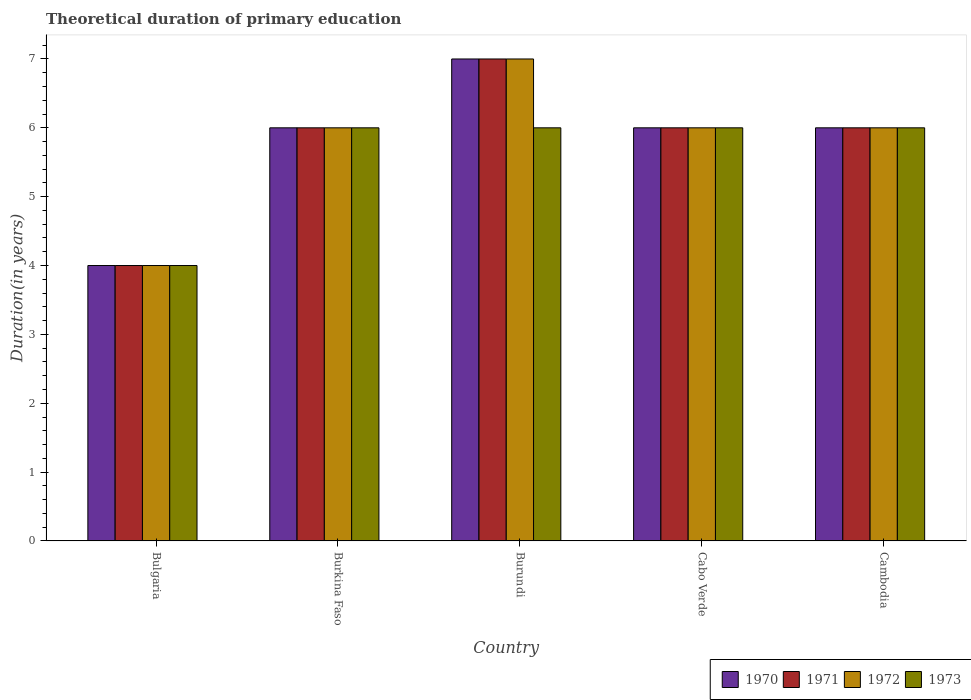Are the number of bars per tick equal to the number of legend labels?
Your answer should be compact. Yes. Are the number of bars on each tick of the X-axis equal?
Offer a terse response. Yes. How many bars are there on the 3rd tick from the right?
Your answer should be compact. 4. What is the label of the 2nd group of bars from the left?
Offer a very short reply. Burkina Faso. In which country was the total theoretical duration of primary education in 1973 maximum?
Your answer should be compact. Burkina Faso. In which country was the total theoretical duration of primary education in 1970 minimum?
Offer a terse response. Bulgaria. What is the total total theoretical duration of primary education in 1971 in the graph?
Your response must be concise. 29. What is the ratio of the total theoretical duration of primary education in 1972 in Bulgaria to that in Cabo Verde?
Provide a succinct answer. 0.67. Is the difference between the total theoretical duration of primary education in 1971 in Bulgaria and Cambodia greater than the difference between the total theoretical duration of primary education in 1972 in Bulgaria and Cambodia?
Make the answer very short. No. What is the difference between the highest and the lowest total theoretical duration of primary education in 1971?
Your response must be concise. 3. Is it the case that in every country, the sum of the total theoretical duration of primary education in 1972 and total theoretical duration of primary education in 1971 is greater than the sum of total theoretical duration of primary education in 1970 and total theoretical duration of primary education in 1973?
Make the answer very short. No. What does the 2nd bar from the left in Cambodia represents?
Provide a short and direct response. 1971. Is it the case that in every country, the sum of the total theoretical duration of primary education in 1970 and total theoretical duration of primary education in 1971 is greater than the total theoretical duration of primary education in 1973?
Your answer should be compact. Yes. How many countries are there in the graph?
Provide a succinct answer. 5. What is the difference between two consecutive major ticks on the Y-axis?
Offer a terse response. 1. Are the values on the major ticks of Y-axis written in scientific E-notation?
Offer a very short reply. No. How many legend labels are there?
Keep it short and to the point. 4. What is the title of the graph?
Offer a terse response. Theoretical duration of primary education. Does "2013" appear as one of the legend labels in the graph?
Your response must be concise. No. What is the label or title of the Y-axis?
Give a very brief answer. Duration(in years). What is the Duration(in years) in 1970 in Bulgaria?
Ensure brevity in your answer.  4. What is the Duration(in years) in 1971 in Bulgaria?
Keep it short and to the point. 4. What is the Duration(in years) of 1972 in Bulgaria?
Ensure brevity in your answer.  4. What is the Duration(in years) of 1973 in Bulgaria?
Your response must be concise. 4. What is the Duration(in years) of 1970 in Burkina Faso?
Provide a succinct answer. 6. What is the Duration(in years) in 1973 in Burkina Faso?
Provide a succinct answer. 6. What is the Duration(in years) in 1970 in Cabo Verde?
Your answer should be compact. 6. What is the Duration(in years) of 1973 in Cabo Verde?
Keep it short and to the point. 6. What is the Duration(in years) in 1971 in Cambodia?
Provide a succinct answer. 6. What is the Duration(in years) of 1972 in Cambodia?
Offer a very short reply. 6. Across all countries, what is the maximum Duration(in years) in 1970?
Provide a short and direct response. 7. Across all countries, what is the maximum Duration(in years) in 1971?
Keep it short and to the point. 7. Across all countries, what is the minimum Duration(in years) of 1970?
Offer a terse response. 4. Across all countries, what is the minimum Duration(in years) of 1971?
Make the answer very short. 4. Across all countries, what is the minimum Duration(in years) in 1972?
Your answer should be compact. 4. What is the total Duration(in years) in 1970 in the graph?
Your answer should be compact. 29. What is the total Duration(in years) of 1971 in the graph?
Provide a succinct answer. 29. What is the total Duration(in years) in 1973 in the graph?
Your answer should be very brief. 28. What is the difference between the Duration(in years) in 1971 in Bulgaria and that in Burkina Faso?
Your response must be concise. -2. What is the difference between the Duration(in years) of 1972 in Bulgaria and that in Burkina Faso?
Provide a succinct answer. -2. What is the difference between the Duration(in years) of 1972 in Bulgaria and that in Burundi?
Give a very brief answer. -3. What is the difference between the Duration(in years) of 1973 in Bulgaria and that in Cabo Verde?
Your answer should be compact. -2. What is the difference between the Duration(in years) of 1970 in Bulgaria and that in Cambodia?
Offer a very short reply. -2. What is the difference between the Duration(in years) of 1972 in Bulgaria and that in Cambodia?
Offer a very short reply. -2. What is the difference between the Duration(in years) of 1970 in Burkina Faso and that in Burundi?
Your answer should be very brief. -1. What is the difference between the Duration(in years) in 1971 in Burkina Faso and that in Burundi?
Your response must be concise. -1. What is the difference between the Duration(in years) of 1972 in Burkina Faso and that in Burundi?
Your response must be concise. -1. What is the difference between the Duration(in years) of 1970 in Burkina Faso and that in Cabo Verde?
Keep it short and to the point. 0. What is the difference between the Duration(in years) in 1971 in Burkina Faso and that in Cabo Verde?
Your response must be concise. 0. What is the difference between the Duration(in years) in 1972 in Burkina Faso and that in Cabo Verde?
Provide a succinct answer. 0. What is the difference between the Duration(in years) in 1973 in Burkina Faso and that in Cabo Verde?
Offer a terse response. 0. What is the difference between the Duration(in years) of 1970 in Burundi and that in Cabo Verde?
Give a very brief answer. 1. What is the difference between the Duration(in years) of 1971 in Burundi and that in Cambodia?
Keep it short and to the point. 1. What is the difference between the Duration(in years) of 1972 in Burundi and that in Cambodia?
Your response must be concise. 1. What is the difference between the Duration(in years) of 1973 in Burundi and that in Cambodia?
Provide a succinct answer. 0. What is the difference between the Duration(in years) in 1970 in Cabo Verde and that in Cambodia?
Provide a succinct answer. 0. What is the difference between the Duration(in years) of 1971 in Cabo Verde and that in Cambodia?
Offer a very short reply. 0. What is the difference between the Duration(in years) of 1972 in Cabo Verde and that in Cambodia?
Provide a succinct answer. 0. What is the difference between the Duration(in years) of 1970 in Bulgaria and the Duration(in years) of 1971 in Burkina Faso?
Make the answer very short. -2. What is the difference between the Duration(in years) in 1970 in Bulgaria and the Duration(in years) in 1973 in Burkina Faso?
Your answer should be compact. -2. What is the difference between the Duration(in years) in 1971 in Bulgaria and the Duration(in years) in 1972 in Burkina Faso?
Your response must be concise. -2. What is the difference between the Duration(in years) of 1971 in Bulgaria and the Duration(in years) of 1973 in Burkina Faso?
Make the answer very short. -2. What is the difference between the Duration(in years) of 1970 in Bulgaria and the Duration(in years) of 1972 in Burundi?
Keep it short and to the point. -3. What is the difference between the Duration(in years) in 1970 in Bulgaria and the Duration(in years) in 1973 in Burundi?
Ensure brevity in your answer.  -2. What is the difference between the Duration(in years) in 1971 in Bulgaria and the Duration(in years) in 1973 in Burundi?
Keep it short and to the point. -2. What is the difference between the Duration(in years) of 1972 in Bulgaria and the Duration(in years) of 1973 in Burundi?
Your answer should be very brief. -2. What is the difference between the Duration(in years) in 1970 in Bulgaria and the Duration(in years) in 1971 in Cabo Verde?
Provide a succinct answer. -2. What is the difference between the Duration(in years) of 1970 in Bulgaria and the Duration(in years) of 1972 in Cambodia?
Make the answer very short. -2. What is the difference between the Duration(in years) in 1970 in Bulgaria and the Duration(in years) in 1973 in Cambodia?
Provide a short and direct response. -2. What is the difference between the Duration(in years) of 1971 in Bulgaria and the Duration(in years) of 1973 in Cambodia?
Make the answer very short. -2. What is the difference between the Duration(in years) in 1970 in Burkina Faso and the Duration(in years) in 1971 in Burundi?
Provide a succinct answer. -1. What is the difference between the Duration(in years) in 1970 in Burkina Faso and the Duration(in years) in 1973 in Burundi?
Ensure brevity in your answer.  0. What is the difference between the Duration(in years) in 1971 in Burkina Faso and the Duration(in years) in 1972 in Burundi?
Ensure brevity in your answer.  -1. What is the difference between the Duration(in years) in 1970 in Burkina Faso and the Duration(in years) in 1971 in Cabo Verde?
Your answer should be compact. 0. What is the difference between the Duration(in years) of 1970 in Burkina Faso and the Duration(in years) of 1972 in Cabo Verde?
Your answer should be very brief. 0. What is the difference between the Duration(in years) of 1970 in Burkina Faso and the Duration(in years) of 1973 in Cabo Verde?
Your answer should be very brief. 0. What is the difference between the Duration(in years) of 1971 in Burkina Faso and the Duration(in years) of 1972 in Cabo Verde?
Offer a terse response. 0. What is the difference between the Duration(in years) of 1971 in Burkina Faso and the Duration(in years) of 1973 in Cabo Verde?
Your answer should be very brief. 0. What is the difference between the Duration(in years) in 1972 in Burkina Faso and the Duration(in years) in 1973 in Cabo Verde?
Keep it short and to the point. 0. What is the difference between the Duration(in years) of 1970 in Burkina Faso and the Duration(in years) of 1971 in Cambodia?
Your response must be concise. 0. What is the difference between the Duration(in years) in 1971 in Burkina Faso and the Duration(in years) in 1972 in Cambodia?
Your answer should be compact. 0. What is the difference between the Duration(in years) in 1970 in Burundi and the Duration(in years) in 1972 in Cabo Verde?
Keep it short and to the point. 1. What is the difference between the Duration(in years) of 1970 in Burundi and the Duration(in years) of 1973 in Cabo Verde?
Provide a short and direct response. 1. What is the difference between the Duration(in years) in 1971 in Burundi and the Duration(in years) in 1973 in Cabo Verde?
Make the answer very short. 1. What is the difference between the Duration(in years) of 1970 in Burundi and the Duration(in years) of 1971 in Cambodia?
Your answer should be compact. 1. What is the difference between the Duration(in years) in 1970 in Burundi and the Duration(in years) in 1973 in Cambodia?
Provide a succinct answer. 1. What is the difference between the Duration(in years) of 1971 in Burundi and the Duration(in years) of 1973 in Cambodia?
Provide a short and direct response. 1. What is the difference between the Duration(in years) of 1972 in Burundi and the Duration(in years) of 1973 in Cambodia?
Your answer should be compact. 1. What is the difference between the Duration(in years) in 1970 in Cabo Verde and the Duration(in years) in 1971 in Cambodia?
Offer a very short reply. 0. What is the difference between the Duration(in years) in 1970 in Cabo Verde and the Duration(in years) in 1972 in Cambodia?
Offer a terse response. 0. What is the difference between the Duration(in years) of 1971 in Cabo Verde and the Duration(in years) of 1972 in Cambodia?
Make the answer very short. 0. What is the average Duration(in years) in 1972 per country?
Your answer should be compact. 5.8. What is the average Duration(in years) in 1973 per country?
Provide a short and direct response. 5.6. What is the difference between the Duration(in years) of 1970 and Duration(in years) of 1971 in Bulgaria?
Provide a short and direct response. 0. What is the difference between the Duration(in years) of 1970 and Duration(in years) of 1973 in Bulgaria?
Your response must be concise. 0. What is the difference between the Duration(in years) of 1971 and Duration(in years) of 1972 in Bulgaria?
Keep it short and to the point. 0. What is the difference between the Duration(in years) in 1971 and Duration(in years) in 1973 in Bulgaria?
Offer a very short reply. 0. What is the difference between the Duration(in years) of 1970 and Duration(in years) of 1972 in Burkina Faso?
Offer a very short reply. 0. What is the difference between the Duration(in years) in 1971 and Duration(in years) in 1972 in Burkina Faso?
Provide a succinct answer. 0. What is the difference between the Duration(in years) of 1972 and Duration(in years) of 1973 in Burkina Faso?
Provide a succinct answer. 0. What is the difference between the Duration(in years) in 1971 and Duration(in years) in 1972 in Burundi?
Provide a succinct answer. 0. What is the difference between the Duration(in years) of 1972 and Duration(in years) of 1973 in Burundi?
Provide a succinct answer. 1. What is the difference between the Duration(in years) in 1970 and Duration(in years) in 1972 in Cabo Verde?
Your answer should be very brief. 0. What is the difference between the Duration(in years) in 1970 and Duration(in years) in 1971 in Cambodia?
Your response must be concise. 0. What is the difference between the Duration(in years) in 1970 and Duration(in years) in 1972 in Cambodia?
Give a very brief answer. 0. What is the difference between the Duration(in years) in 1971 and Duration(in years) in 1973 in Cambodia?
Your answer should be compact. 0. What is the ratio of the Duration(in years) of 1972 in Bulgaria to that in Burkina Faso?
Keep it short and to the point. 0.67. What is the ratio of the Duration(in years) of 1973 in Bulgaria to that in Burkina Faso?
Provide a succinct answer. 0.67. What is the ratio of the Duration(in years) in 1971 in Bulgaria to that in Burundi?
Offer a very short reply. 0.57. What is the ratio of the Duration(in years) in 1973 in Bulgaria to that in Burundi?
Offer a terse response. 0.67. What is the ratio of the Duration(in years) of 1971 in Bulgaria to that in Cabo Verde?
Provide a succinct answer. 0.67. What is the ratio of the Duration(in years) in 1972 in Bulgaria to that in Cabo Verde?
Your answer should be compact. 0.67. What is the ratio of the Duration(in years) of 1971 in Burkina Faso to that in Burundi?
Keep it short and to the point. 0.86. What is the ratio of the Duration(in years) of 1972 in Burkina Faso to that in Burundi?
Ensure brevity in your answer.  0.86. What is the ratio of the Duration(in years) in 1973 in Burkina Faso to that in Burundi?
Provide a succinct answer. 1. What is the ratio of the Duration(in years) in 1970 in Burkina Faso to that in Cabo Verde?
Your answer should be compact. 1. What is the ratio of the Duration(in years) of 1973 in Burkina Faso to that in Cabo Verde?
Keep it short and to the point. 1. What is the ratio of the Duration(in years) of 1972 in Burkina Faso to that in Cambodia?
Ensure brevity in your answer.  1. What is the ratio of the Duration(in years) in 1973 in Burkina Faso to that in Cambodia?
Keep it short and to the point. 1. What is the ratio of the Duration(in years) in 1970 in Burundi to that in Cabo Verde?
Give a very brief answer. 1.17. What is the ratio of the Duration(in years) of 1971 in Burundi to that in Cabo Verde?
Provide a succinct answer. 1.17. What is the ratio of the Duration(in years) in 1971 in Burundi to that in Cambodia?
Your answer should be very brief. 1.17. What is the ratio of the Duration(in years) in 1972 in Burundi to that in Cambodia?
Your response must be concise. 1.17. What is the ratio of the Duration(in years) of 1971 in Cabo Verde to that in Cambodia?
Your response must be concise. 1. What is the ratio of the Duration(in years) of 1972 in Cabo Verde to that in Cambodia?
Your response must be concise. 1. What is the ratio of the Duration(in years) of 1973 in Cabo Verde to that in Cambodia?
Your answer should be compact. 1. What is the difference between the highest and the second highest Duration(in years) of 1970?
Your answer should be very brief. 1. What is the difference between the highest and the second highest Duration(in years) in 1971?
Provide a succinct answer. 1. What is the difference between the highest and the second highest Duration(in years) in 1972?
Your answer should be compact. 1. 